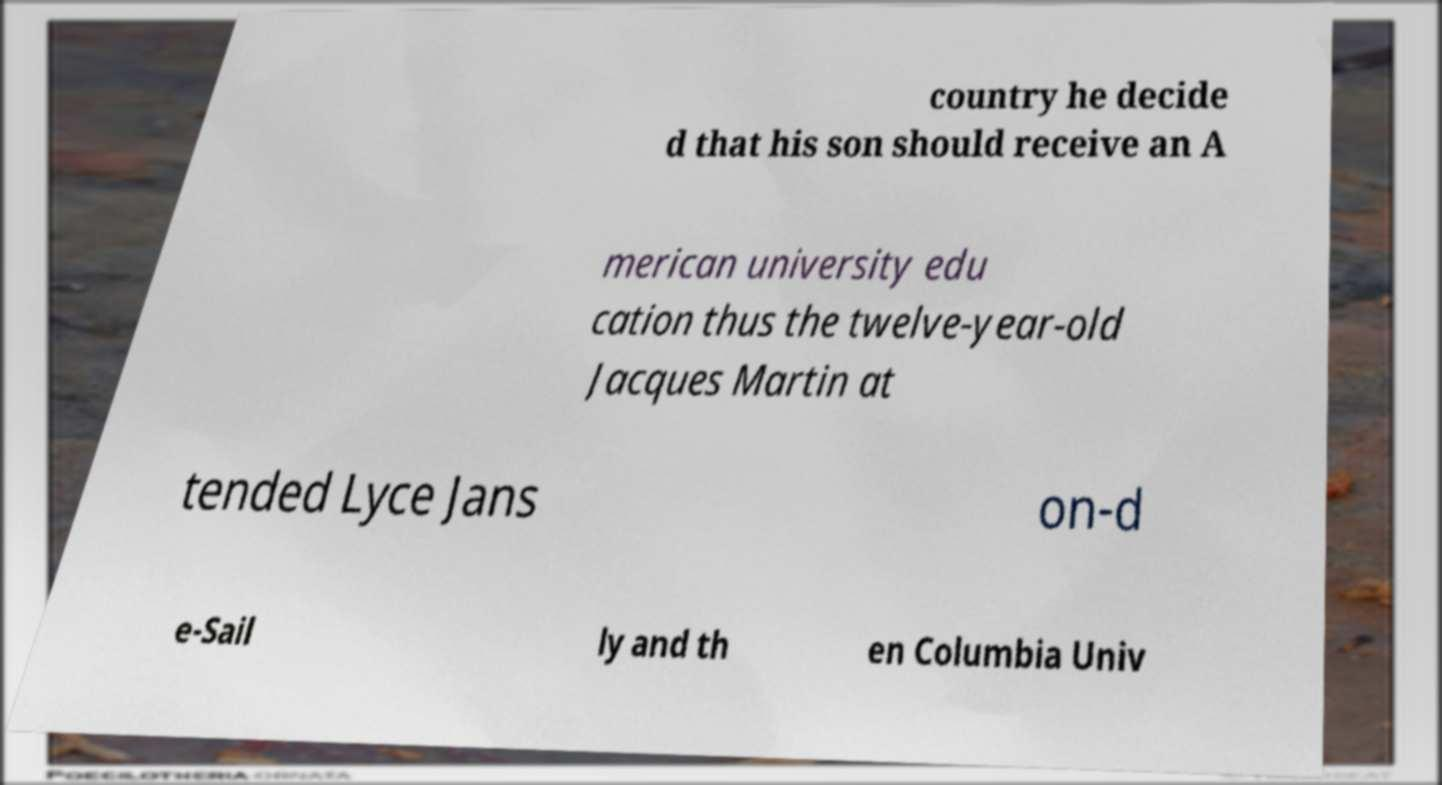Please identify and transcribe the text found in this image. country he decide d that his son should receive an A merican university edu cation thus the twelve-year-old Jacques Martin at tended Lyce Jans on-d e-Sail ly and th en Columbia Univ 